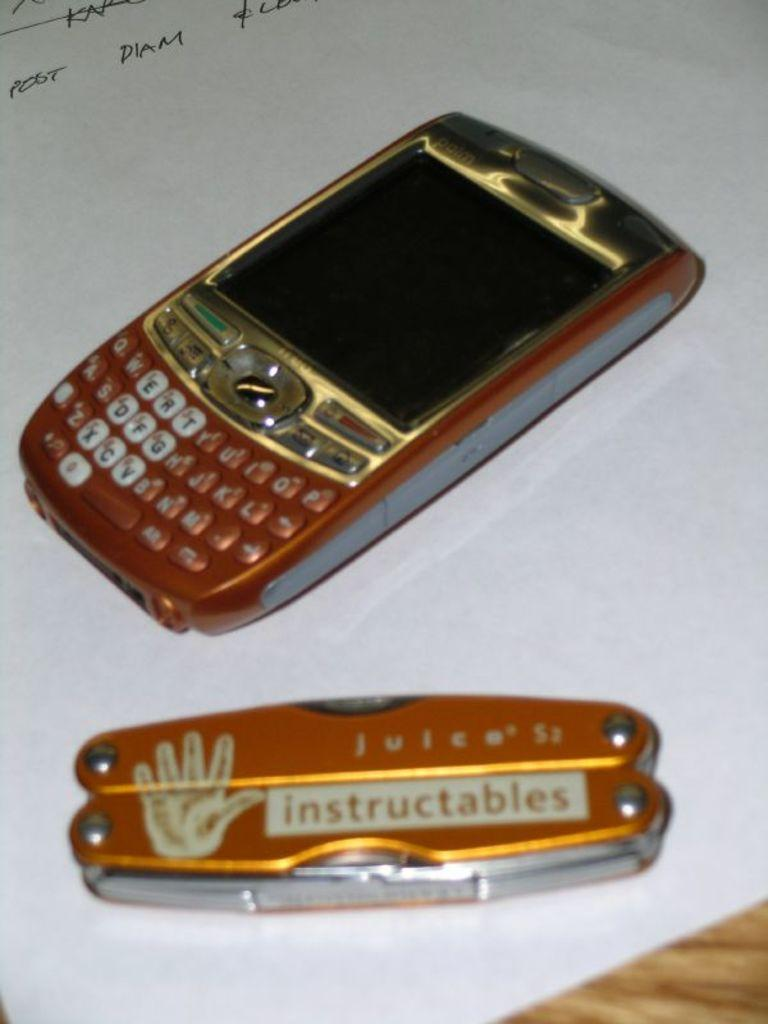<image>
Give a short and clear explanation of the subsequent image. A burnt orange colored Blackberry phone is next to a pocket knife of the same color with the words instructables on it. 